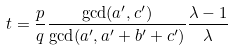Convert formula to latex. <formula><loc_0><loc_0><loc_500><loc_500>t = \frac { p } { q } \frac { \gcd ( a ^ { \prime } , c ^ { \prime } ) } { \gcd ( a ^ { \prime } , a ^ { \prime } + b ^ { \prime } + c ^ { \prime } ) } \frac { \lambda - 1 } { \lambda }</formula> 